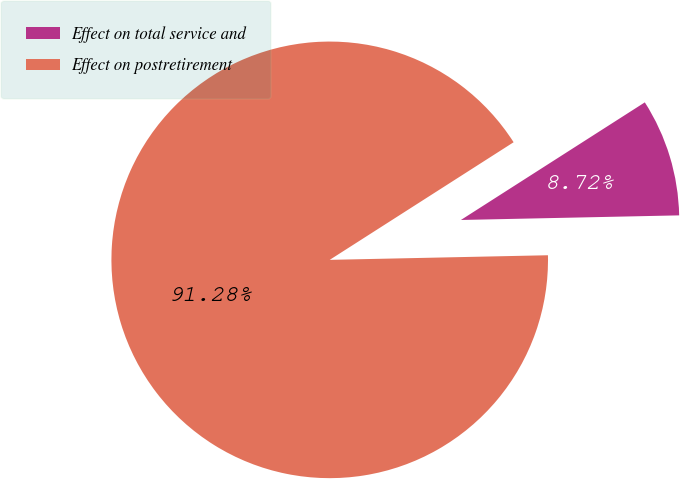Convert chart to OTSL. <chart><loc_0><loc_0><loc_500><loc_500><pie_chart><fcel>Effect on total service and<fcel>Effect on postretirement<nl><fcel>8.72%<fcel>91.28%<nl></chart> 